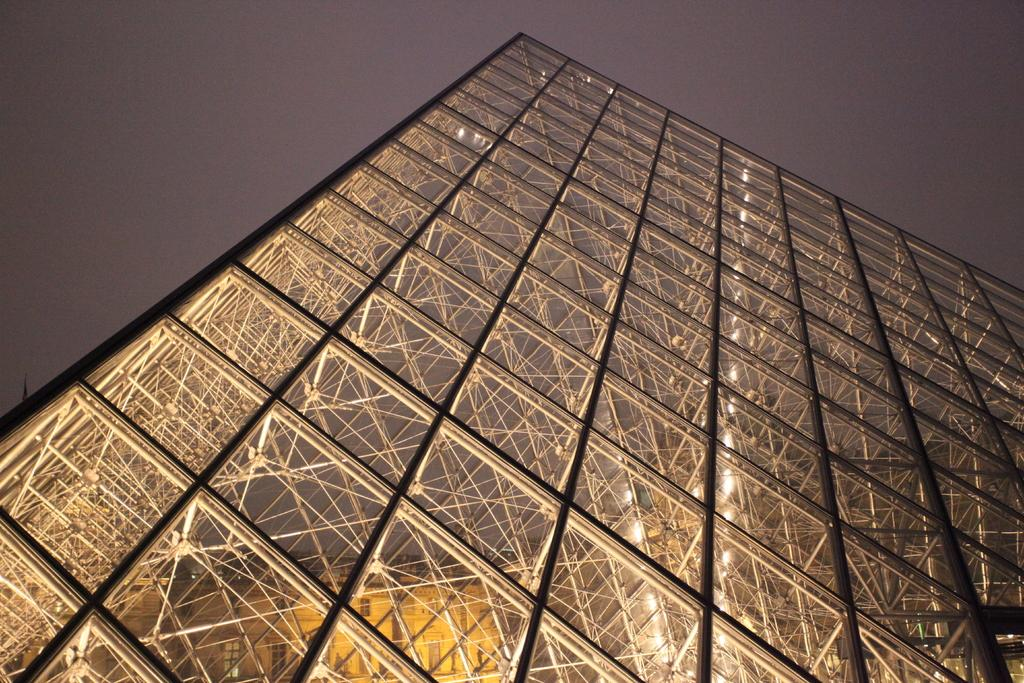What is the main subject in the image? There is a structure in the image that resembles a building. What can be seen in the background of the image? The sky is visible at the top of the image. How far away is the drain from the building in the image? There is no drain present in the image, so it is not possible to determine the distance between it and the building. 